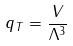<formula> <loc_0><loc_0><loc_500><loc_500>q _ { T } = \frac { V } { \Lambda ^ { 3 } }</formula> 